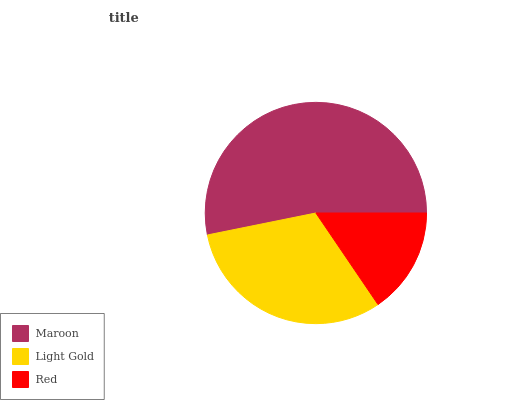Is Red the minimum?
Answer yes or no. Yes. Is Maroon the maximum?
Answer yes or no. Yes. Is Light Gold the minimum?
Answer yes or no. No. Is Light Gold the maximum?
Answer yes or no. No. Is Maroon greater than Light Gold?
Answer yes or no. Yes. Is Light Gold less than Maroon?
Answer yes or no. Yes. Is Light Gold greater than Maroon?
Answer yes or no. No. Is Maroon less than Light Gold?
Answer yes or no. No. Is Light Gold the high median?
Answer yes or no. Yes. Is Light Gold the low median?
Answer yes or no. Yes. Is Red the high median?
Answer yes or no. No. Is Red the low median?
Answer yes or no. No. 